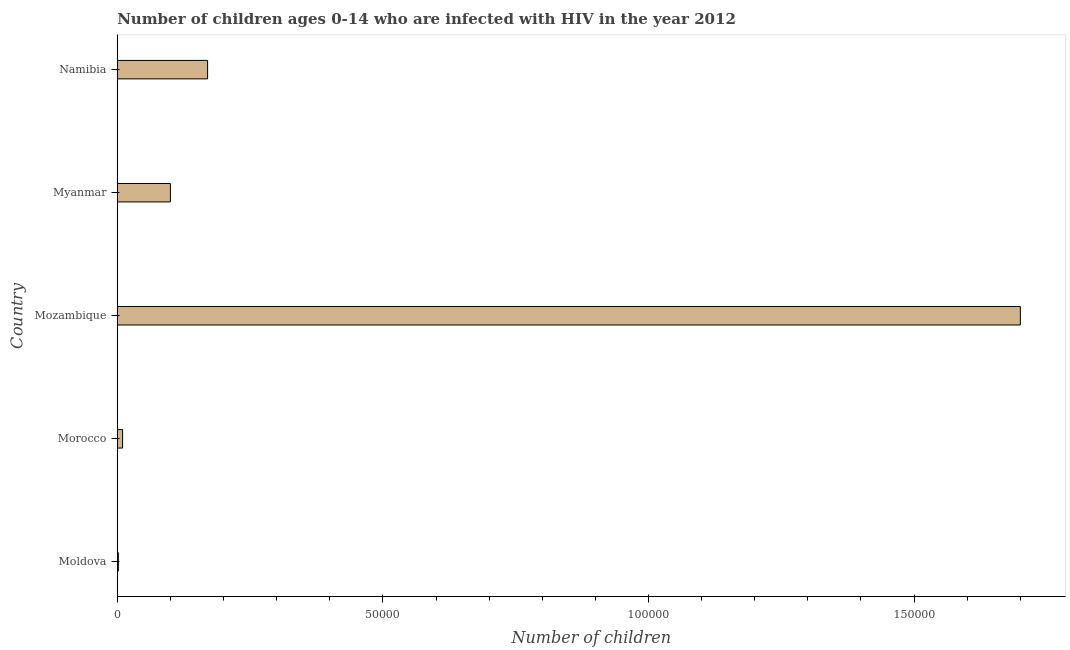Does the graph contain any zero values?
Offer a terse response. No. Does the graph contain grids?
Provide a succinct answer. No. What is the title of the graph?
Provide a succinct answer. Number of children ages 0-14 who are infected with HIV in the year 2012. What is the label or title of the X-axis?
Your response must be concise. Number of children. Across all countries, what is the maximum number of children living with hiv?
Keep it short and to the point. 1.70e+05. In which country was the number of children living with hiv maximum?
Make the answer very short. Mozambique. In which country was the number of children living with hiv minimum?
Your response must be concise. Moldova. What is the sum of the number of children living with hiv?
Ensure brevity in your answer.  1.98e+05. What is the difference between the number of children living with hiv in Moldova and Mozambique?
Offer a terse response. -1.70e+05. What is the average number of children living with hiv per country?
Provide a succinct answer. 3.96e+04. What is the ratio of the number of children living with hiv in Moldova to that in Morocco?
Make the answer very short. 0.2. Is the number of children living with hiv in Mozambique less than that in Namibia?
Your response must be concise. No. Is the difference between the number of children living with hiv in Moldova and Namibia greater than the difference between any two countries?
Offer a terse response. No. What is the difference between the highest and the second highest number of children living with hiv?
Ensure brevity in your answer.  1.53e+05. What is the difference between the highest and the lowest number of children living with hiv?
Your response must be concise. 1.70e+05. How many bars are there?
Offer a terse response. 5. Are all the bars in the graph horizontal?
Provide a succinct answer. Yes. Are the values on the major ticks of X-axis written in scientific E-notation?
Make the answer very short. No. What is the Number of children in Myanmar?
Offer a very short reply. 10000. What is the Number of children of Namibia?
Your response must be concise. 1.70e+04. What is the difference between the Number of children in Moldova and Morocco?
Ensure brevity in your answer.  -800. What is the difference between the Number of children in Moldova and Mozambique?
Provide a succinct answer. -1.70e+05. What is the difference between the Number of children in Moldova and Myanmar?
Your answer should be very brief. -9800. What is the difference between the Number of children in Moldova and Namibia?
Your answer should be very brief. -1.68e+04. What is the difference between the Number of children in Morocco and Mozambique?
Give a very brief answer. -1.69e+05. What is the difference between the Number of children in Morocco and Myanmar?
Ensure brevity in your answer.  -9000. What is the difference between the Number of children in Morocco and Namibia?
Offer a very short reply. -1.60e+04. What is the difference between the Number of children in Mozambique and Namibia?
Keep it short and to the point. 1.53e+05. What is the difference between the Number of children in Myanmar and Namibia?
Provide a succinct answer. -7000. What is the ratio of the Number of children in Moldova to that in Morocco?
Give a very brief answer. 0.2. What is the ratio of the Number of children in Moldova to that in Namibia?
Keep it short and to the point. 0.01. What is the ratio of the Number of children in Morocco to that in Mozambique?
Ensure brevity in your answer.  0.01. What is the ratio of the Number of children in Morocco to that in Namibia?
Offer a very short reply. 0.06. What is the ratio of the Number of children in Mozambique to that in Myanmar?
Provide a succinct answer. 17. What is the ratio of the Number of children in Mozambique to that in Namibia?
Offer a terse response. 10. What is the ratio of the Number of children in Myanmar to that in Namibia?
Give a very brief answer. 0.59. 